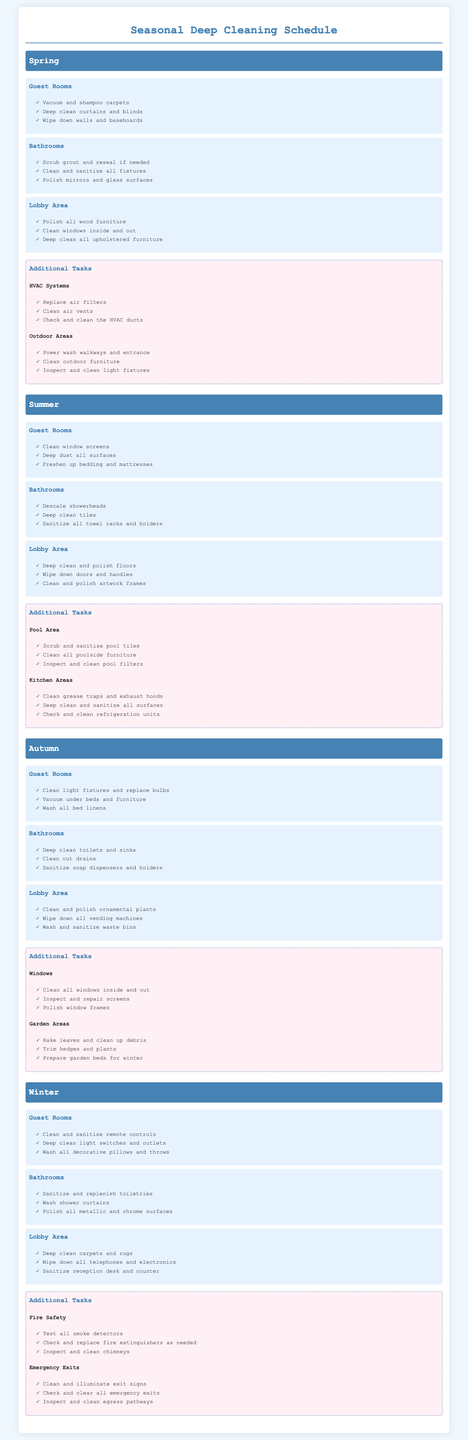What tasks are included for Guest Rooms in Spring? The tasks for Guest Rooms in Spring include vacuuming and shampooing carpets, deep cleaning curtains and blinds, and wiping down walls and baseboards.
Answer: Vacuum and shampoo carpets, Deep clean curtains and blinds, Wipe down walls and baseboards How many areas are deep cleaned in Summer? The Summer section lists three areas: Guest Rooms, Bathrooms, and Lobby Area.
Answer: 3 What task is assigned for the Pool Area in Summer? The Pool Area tasks include scrubbing and sanitizing pool tiles, cleaning poolside furniture, and inspecting pool filters.
Answer: Scrub and sanitize pool tiles What is a unique task for the Bathrooms in Winter? The Bathrooms in Winter include sanitizing and replenishing toiletries, which is specific to this season.
Answer: Sanitize and replenish toiletries Which season includes tasks related to outdoor areas? The Spring season lists tasks for Outdoor Areas including power washing walkways and inspecting light fixtures.
Answer: Spring What cleaning task is specified for the Lobby Area in Autumn? The Lobby Area in Autumn includes cleaning and polishing ornamental plants.
Answer: Clean and polish ornamental plants How many additional tasks are mentioned for Winter? The Winter section has two categories of additional tasks: Fire Safety and Emergency Exits.
Answer: 2 What type of cleaning is done for carpets in the Lobby Area during Winter? The task specified for carpets in the Winter is deep cleaning.
Answer: Deep clean carpets and rugs 